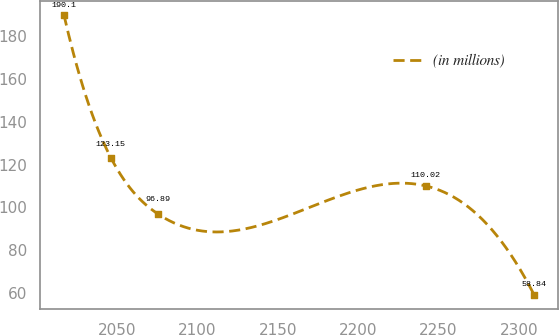<chart> <loc_0><loc_0><loc_500><loc_500><line_chart><ecel><fcel>(in millions)<nl><fcel>2016.88<fcel>190.1<nl><fcel>2046.15<fcel>123.15<nl><fcel>2075.42<fcel>96.89<nl><fcel>2242.02<fcel>110.02<nl><fcel>2309.61<fcel>58.84<nl></chart> 